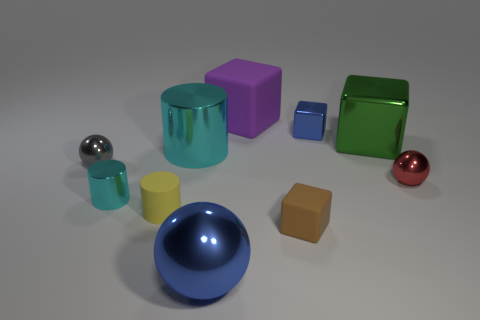How many cyan metallic things are the same shape as the tiny yellow thing?
Provide a short and direct response. 2. What is the size of the red sphere that is made of the same material as the tiny blue thing?
Give a very brief answer. Small. What color is the small metallic thing that is both behind the tiny red sphere and on the left side of the large purple rubber object?
Offer a terse response. Gray. How many red rubber things have the same size as the blue ball?
Your answer should be very brief. 0. What is the size of the cube that is the same color as the big sphere?
Provide a succinct answer. Small. What size is the matte thing that is both right of the tiny yellow cylinder and in front of the big cyan cylinder?
Make the answer very short. Small. There is a rubber cube that is behind the shiny ball that is on the right side of the big purple thing; what number of metal balls are behind it?
Provide a short and direct response. 0. Is there a metal ball that has the same color as the small matte cube?
Offer a terse response. No. What color is the rubber cylinder that is the same size as the brown rubber cube?
Ensure brevity in your answer.  Yellow. There is a big metal object that is on the left side of the big metal ball to the left of the small ball right of the tiny brown object; what is its shape?
Ensure brevity in your answer.  Cylinder. 